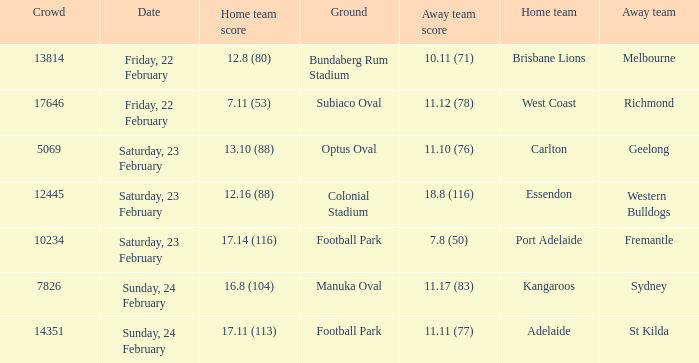I'm looking to parse the entire table for insights. Could you assist me with that? {'header': ['Crowd', 'Date', 'Home team score', 'Ground', 'Away team score', 'Home team', 'Away team'], 'rows': [['13814', 'Friday, 22 February', '12.8 (80)', 'Bundaberg Rum Stadium', '10.11 (71)', 'Brisbane Lions', 'Melbourne'], ['17646', 'Friday, 22 February', '7.11 (53)', 'Subiaco Oval', '11.12 (78)', 'West Coast', 'Richmond'], ['5069', 'Saturday, 23 February', '13.10 (88)', 'Optus Oval', '11.10 (76)', 'Carlton', 'Geelong'], ['12445', 'Saturday, 23 February', '12.16 (88)', 'Colonial Stadium', '18.8 (116)', 'Essendon', 'Western Bulldogs'], ['10234', 'Saturday, 23 February', '17.14 (116)', 'Football Park', '7.8 (50)', 'Port Adelaide', 'Fremantle'], ['7826', 'Sunday, 24 February', '16.8 (104)', 'Manuka Oval', '11.17 (83)', 'Kangaroos', 'Sydney'], ['14351', 'Sunday, 24 February', '17.11 (113)', 'Football Park', '11.11 (77)', 'Adelaide', 'St Kilda']]} Where the home team scored 13.10 (88), what was the size of the crowd? 5069.0. 